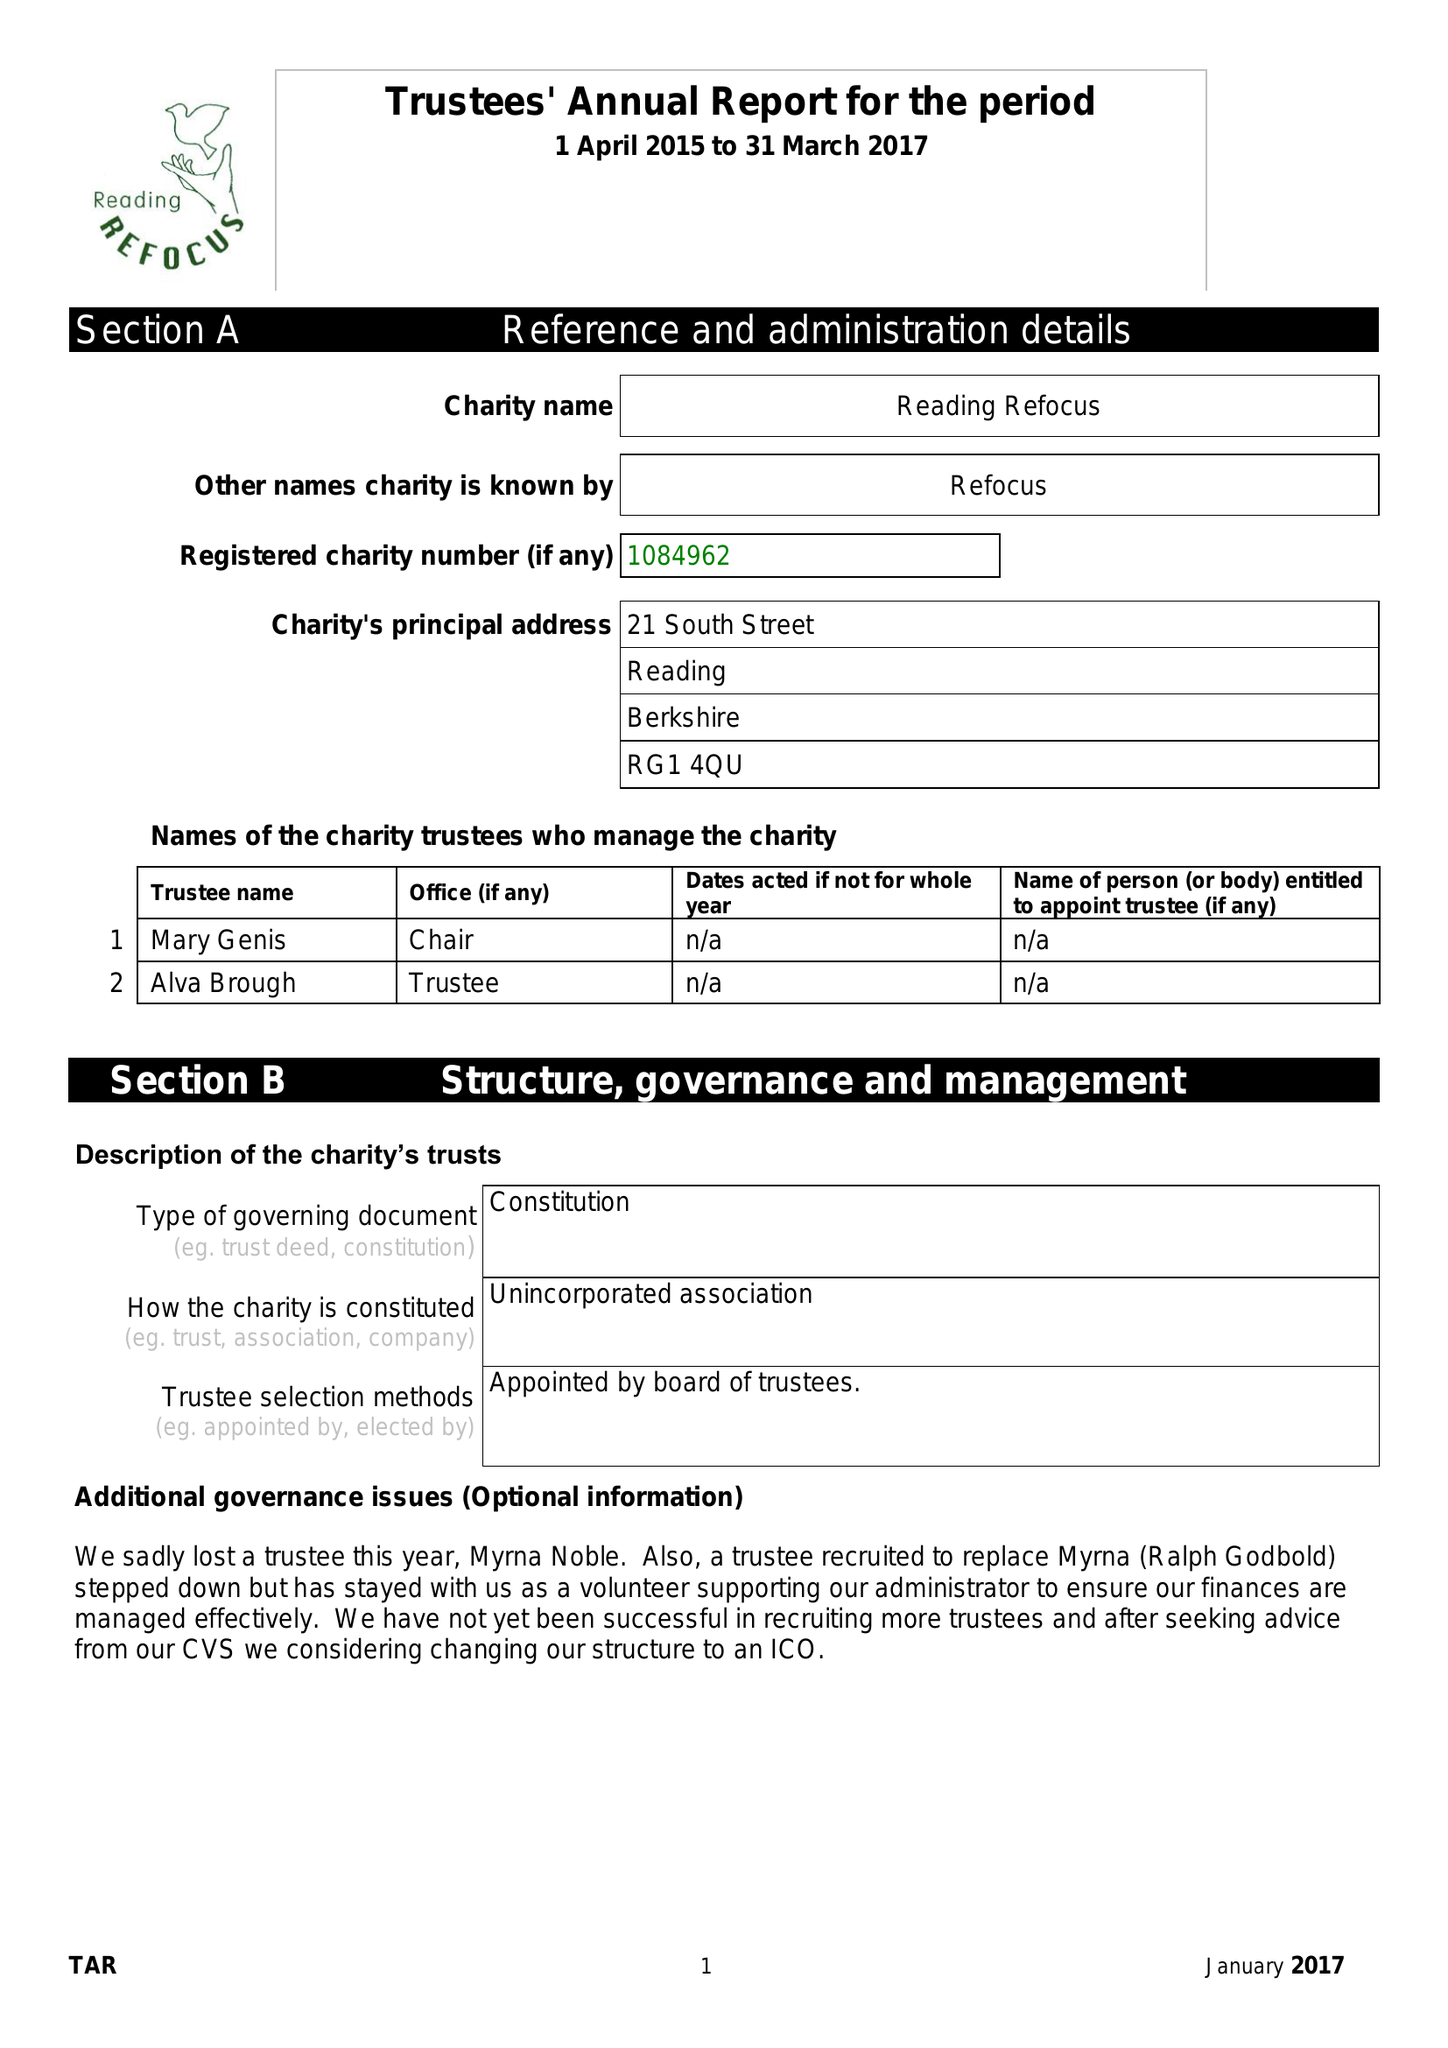What is the value for the address__post_town?
Answer the question using a single word or phrase. READING 